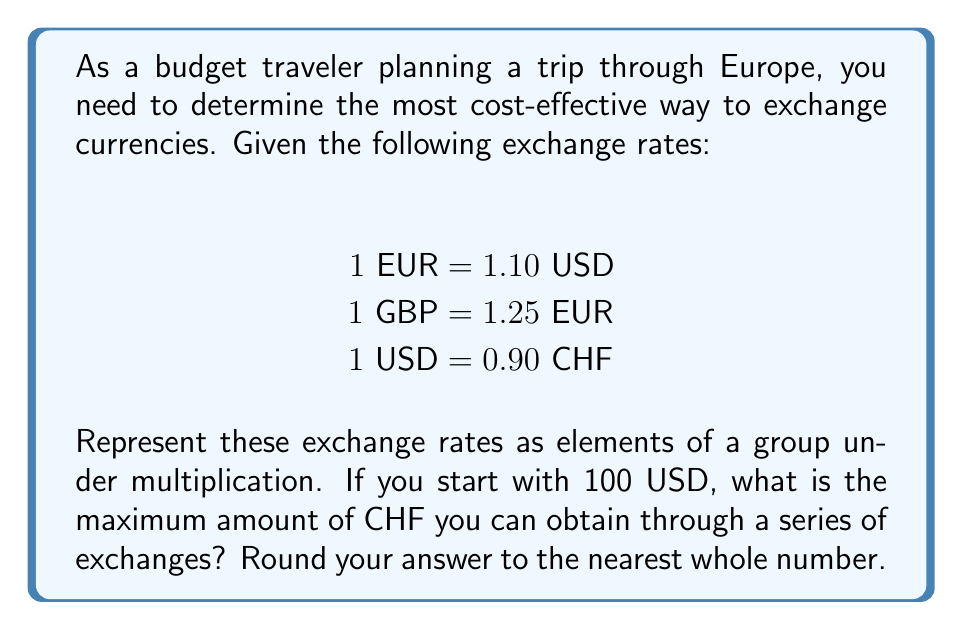Teach me how to tackle this problem. Let's approach this problem using group theory concepts:

1) First, we'll represent the exchange rates as a group under multiplication. Let's define the group elements as follows:

   $a = 1.10$ (USD to EUR)
   $b = 1.25$ (EUR to GBP)
   $c = 1/0.90 = 1.11111...$ (CHF to USD)

2) The group operation is multiplication, representing successive currency exchanges.

3) To find the maximum CHF from 100 USD, we need to find the largest product of these elements (and their inverses) that results in a USD to CHF conversion.

4) The possible paths are:
   
   USD → EUR → GBP → EUR → CHF: $100 * a * b * (1/b) * (1/c) = 100 * a * (1/c)$
   USD → EUR → CHF: $100 * a * (1/c)$
   USD → CHF: $100 * (1/c)$

5) Let's calculate each:

   $100 * a * (1/c) = 100 * 1.10 * 0.90 = 99$ CHF
   $100 * (1/c) = 100 * 0.90 = 90$ CHF

6) The maximum is achieved through USD → EUR → CHF, resulting in 99 CHF.

This problem demonstrates the use of group theory in representing and analyzing currency exchange rates. The exchange rates form a group under multiplication, with the identity element being 1 (no change in currency) and each rate having an inverse (the reciprocal rate for the opposite exchange).
Answer: 99 CHF 